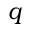Convert formula to latex. <formula><loc_0><loc_0><loc_500><loc_500>q</formula> 